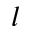Convert formula to latex. <formula><loc_0><loc_0><loc_500><loc_500>l</formula> 